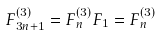Convert formula to latex. <formula><loc_0><loc_0><loc_500><loc_500>F _ { 3 n + 1 } ^ { \left ( 3 \right ) } = F _ { n } ^ { \left ( 3 \right ) } F _ { 1 } = F _ { n } ^ { \left ( 3 \right ) }</formula> 